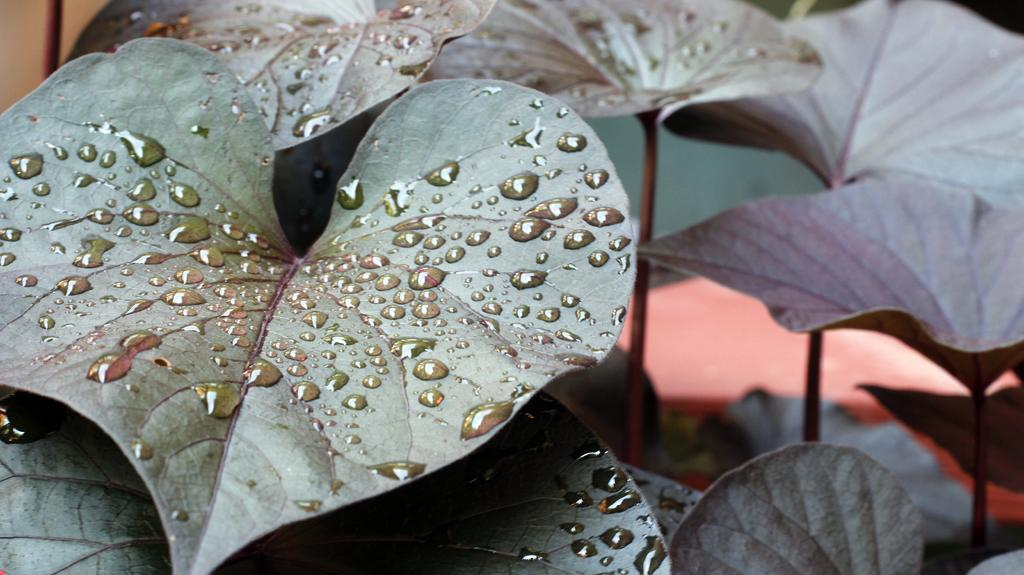What type of vegetation can be seen in the image? There are leaves in the image. What is present on the leaves in the image? There are water droplets on the leaves. How would you describe the background of the image? The background of the image is blurry. What type of secretary can be seen working in the library in the image? There is no secretary or library present in the image; it only features leaves with water droplets and a blurry background. 